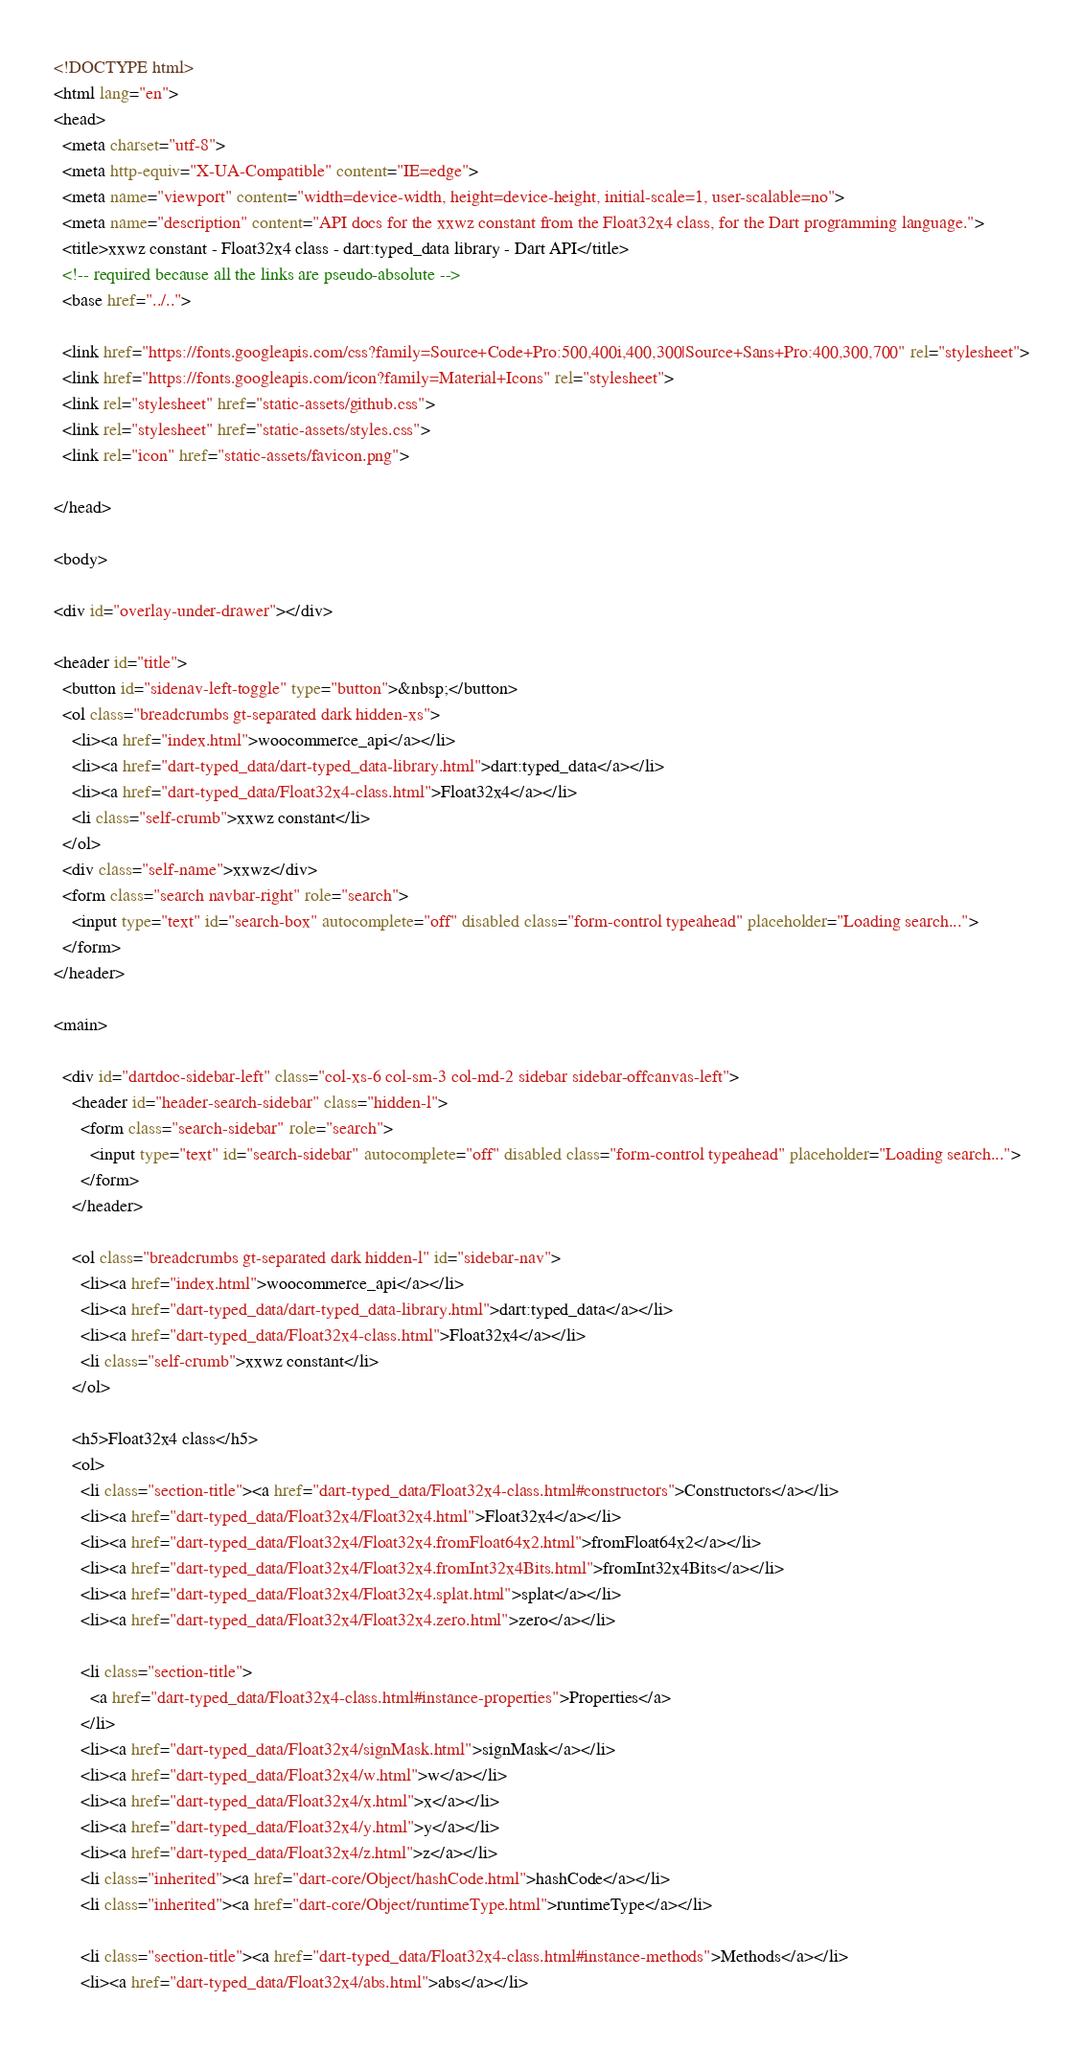<code> <loc_0><loc_0><loc_500><loc_500><_HTML_><!DOCTYPE html>
<html lang="en">
<head>
  <meta charset="utf-8">
  <meta http-equiv="X-UA-Compatible" content="IE=edge">
  <meta name="viewport" content="width=device-width, height=device-height, initial-scale=1, user-scalable=no">
  <meta name="description" content="API docs for the xxwz constant from the Float32x4 class, for the Dart programming language.">
  <title>xxwz constant - Float32x4 class - dart:typed_data library - Dart API</title>
  <!-- required because all the links are pseudo-absolute -->
  <base href="../..">

  <link href="https://fonts.googleapis.com/css?family=Source+Code+Pro:500,400i,400,300|Source+Sans+Pro:400,300,700" rel="stylesheet">
  <link href="https://fonts.googleapis.com/icon?family=Material+Icons" rel="stylesheet">
  <link rel="stylesheet" href="static-assets/github.css">
  <link rel="stylesheet" href="static-assets/styles.css">
  <link rel="icon" href="static-assets/favicon.png">
  
</head>

<body>

<div id="overlay-under-drawer"></div>

<header id="title">
  <button id="sidenav-left-toggle" type="button">&nbsp;</button>
  <ol class="breadcrumbs gt-separated dark hidden-xs">
    <li><a href="index.html">woocommerce_api</a></li>
    <li><a href="dart-typed_data/dart-typed_data-library.html">dart:typed_data</a></li>
    <li><a href="dart-typed_data/Float32x4-class.html">Float32x4</a></li>
    <li class="self-crumb">xxwz constant</li>
  </ol>
  <div class="self-name">xxwz</div>
  <form class="search navbar-right" role="search">
    <input type="text" id="search-box" autocomplete="off" disabled class="form-control typeahead" placeholder="Loading search...">
  </form>
</header>

<main>

  <div id="dartdoc-sidebar-left" class="col-xs-6 col-sm-3 col-md-2 sidebar sidebar-offcanvas-left">
    <header id="header-search-sidebar" class="hidden-l">
      <form class="search-sidebar" role="search">
        <input type="text" id="search-sidebar" autocomplete="off" disabled class="form-control typeahead" placeholder="Loading search...">
      </form>
    </header>
    
    <ol class="breadcrumbs gt-separated dark hidden-l" id="sidebar-nav">
      <li><a href="index.html">woocommerce_api</a></li>
      <li><a href="dart-typed_data/dart-typed_data-library.html">dart:typed_data</a></li>
      <li><a href="dart-typed_data/Float32x4-class.html">Float32x4</a></li>
      <li class="self-crumb">xxwz constant</li>
    </ol>
    
    <h5>Float32x4 class</h5>
    <ol>
      <li class="section-title"><a href="dart-typed_data/Float32x4-class.html#constructors">Constructors</a></li>
      <li><a href="dart-typed_data/Float32x4/Float32x4.html">Float32x4</a></li>
      <li><a href="dart-typed_data/Float32x4/Float32x4.fromFloat64x2.html">fromFloat64x2</a></li>
      <li><a href="dart-typed_data/Float32x4/Float32x4.fromInt32x4Bits.html">fromInt32x4Bits</a></li>
      <li><a href="dart-typed_data/Float32x4/Float32x4.splat.html">splat</a></li>
      <li><a href="dart-typed_data/Float32x4/Float32x4.zero.html">zero</a></li>
    
      <li class="section-title">
        <a href="dart-typed_data/Float32x4-class.html#instance-properties">Properties</a>
      </li>
      <li><a href="dart-typed_data/Float32x4/signMask.html">signMask</a></li>
      <li><a href="dart-typed_data/Float32x4/w.html">w</a></li>
      <li><a href="dart-typed_data/Float32x4/x.html">x</a></li>
      <li><a href="dart-typed_data/Float32x4/y.html">y</a></li>
      <li><a href="dart-typed_data/Float32x4/z.html">z</a></li>
      <li class="inherited"><a href="dart-core/Object/hashCode.html">hashCode</a></li>
      <li class="inherited"><a href="dart-core/Object/runtimeType.html">runtimeType</a></li>
    
      <li class="section-title"><a href="dart-typed_data/Float32x4-class.html#instance-methods">Methods</a></li>
      <li><a href="dart-typed_data/Float32x4/abs.html">abs</a></li></code> 